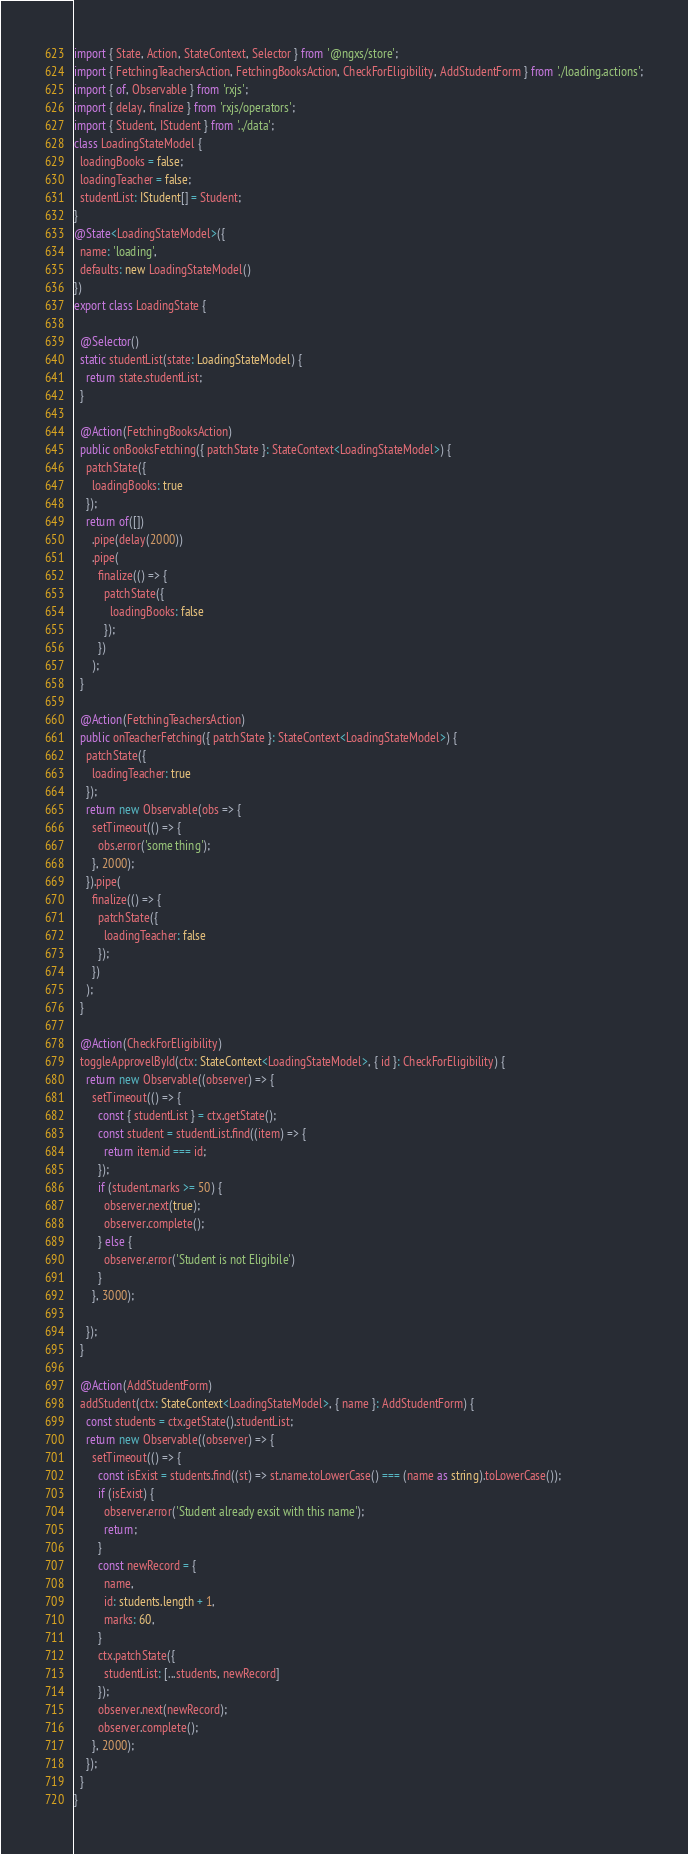Convert code to text. <code><loc_0><loc_0><loc_500><loc_500><_TypeScript_>import { State, Action, StateContext, Selector } from '@ngxs/store';
import { FetchingTeachersAction, FetchingBooksAction, CheckForEligibility, AddStudentForm } from './loading.actions';
import { of, Observable } from 'rxjs';
import { delay, finalize } from 'rxjs/operators';
import { Student, IStudent } from '../data';
class LoadingStateModel {
  loadingBooks = false;
  loadingTeacher = false;
  studentList: IStudent[] = Student;
}
@State<LoadingStateModel>({
  name: 'loading',
  defaults: new LoadingStateModel()
})
export class LoadingState {

  @Selector()
  static studentList(state: LoadingStateModel) {
    return state.studentList;
  }

  @Action(FetchingBooksAction)
  public onBooksFetching({ patchState }: StateContext<LoadingStateModel>) {
    patchState({
      loadingBooks: true
    });
    return of([])
      .pipe(delay(2000))
      .pipe(
        finalize(() => {
          patchState({
            loadingBooks: false
          });
        })
      );
  }

  @Action(FetchingTeachersAction)
  public onTeacherFetching({ patchState }: StateContext<LoadingStateModel>) {
    patchState({
      loadingTeacher: true
    });
    return new Observable(obs => {
      setTimeout(() => {
        obs.error('some thing');
      }, 2000);
    }).pipe(
      finalize(() => {
        patchState({
          loadingTeacher: false
        });
      })
    );
  }

  @Action(CheckForEligibility)
  toggleApprovelById(ctx: StateContext<LoadingStateModel>, { id }: CheckForEligibility) {
    return new Observable((observer) => {
      setTimeout(() => {
        const { studentList } = ctx.getState();
        const student = studentList.find((item) => {
          return item.id === id;
        });
        if (student.marks >= 50) {
          observer.next(true);
          observer.complete();
        } else {
          observer.error('Student is not Eligibile')
        }
      }, 3000);

    });
  }

  @Action(AddStudentForm)
  addStudent(ctx: StateContext<LoadingStateModel>, { name }: AddStudentForm) {
    const students = ctx.getState().studentList;
    return new Observable((observer) => {
      setTimeout(() => {
        const isExist = students.find((st) => st.name.toLowerCase() === (name as string).toLowerCase());
        if (isExist) {
          observer.error('Student already exsit with this name');
          return;
        }
        const newRecord = {
          name,
          id: students.length + 1,
          marks: 60,
        }
        ctx.patchState({
          studentList: [...students, newRecord]
        });
        observer.next(newRecord);
        observer.complete();
      }, 2000);
    });
  }
}
</code> 